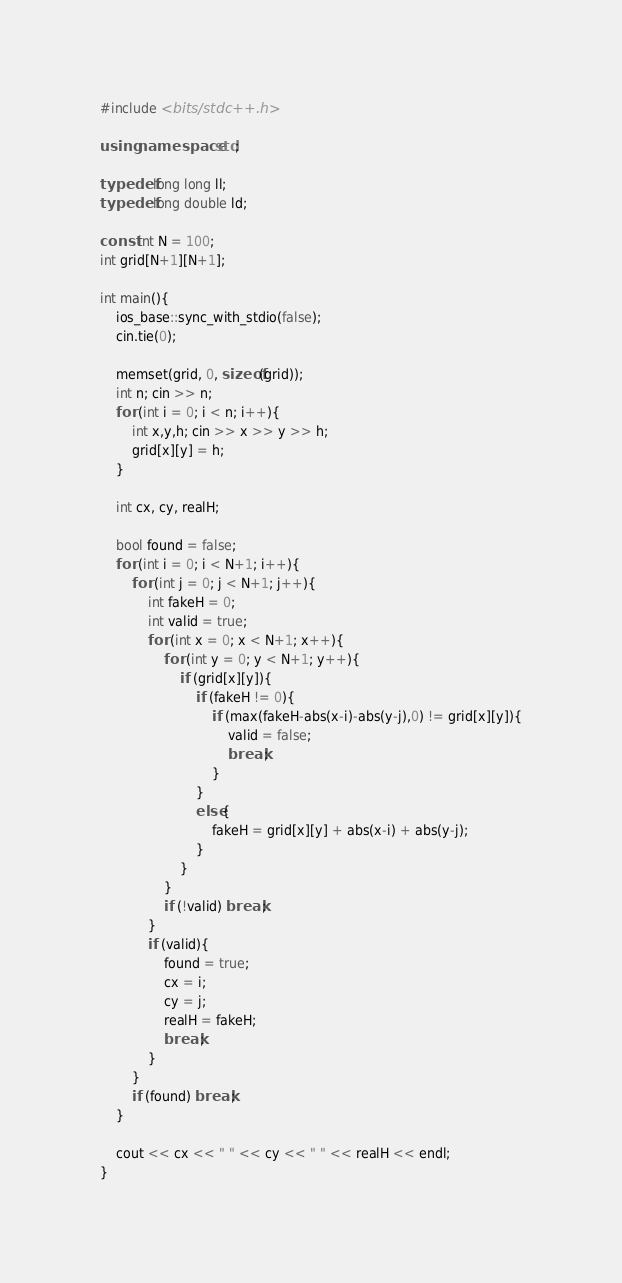Convert code to text. <code><loc_0><loc_0><loc_500><loc_500><_C++_>#include <bits/stdc++.h>
 
using namespace std;

typedef long long ll;
typedef long double ld;

const int N = 100;
int grid[N+1][N+1];

int main(){
	ios_base::sync_with_stdio(false);
	cin.tie(0);
	
	memset(grid, 0, sizeof(grid));
	int n; cin >> n;
	for (int i = 0; i < n; i++){
		int x,y,h; cin >> x >> y >> h;	
		grid[x][y] = h;
	}
	
	int cx, cy, realH;
	
	bool found = false;
	for (int i = 0; i < N+1; i++){
		for (int j = 0; j < N+1; j++){
			int fakeH = 0;
			int valid = true;
			for (int x = 0; x < N+1; x++){
				for (int y = 0; y < N+1; y++){
					if (grid[x][y]){
						if (fakeH != 0){
							if (max(fakeH-abs(x-i)-abs(y-j),0) != grid[x][y]){
								valid = false;
								break;
							}
						}
						else{
							fakeH = grid[x][y] + abs(x-i) + abs(y-j);
						}
					}
				}
				if (!valid) break;
			}
			if (valid){
				found = true;
				cx = i;
				cy = j;
				realH = fakeH;
				break;
			}
		}
		if (found) break;
	}
	
	cout << cx << " " << cy << " " << realH << endl;
}</code> 